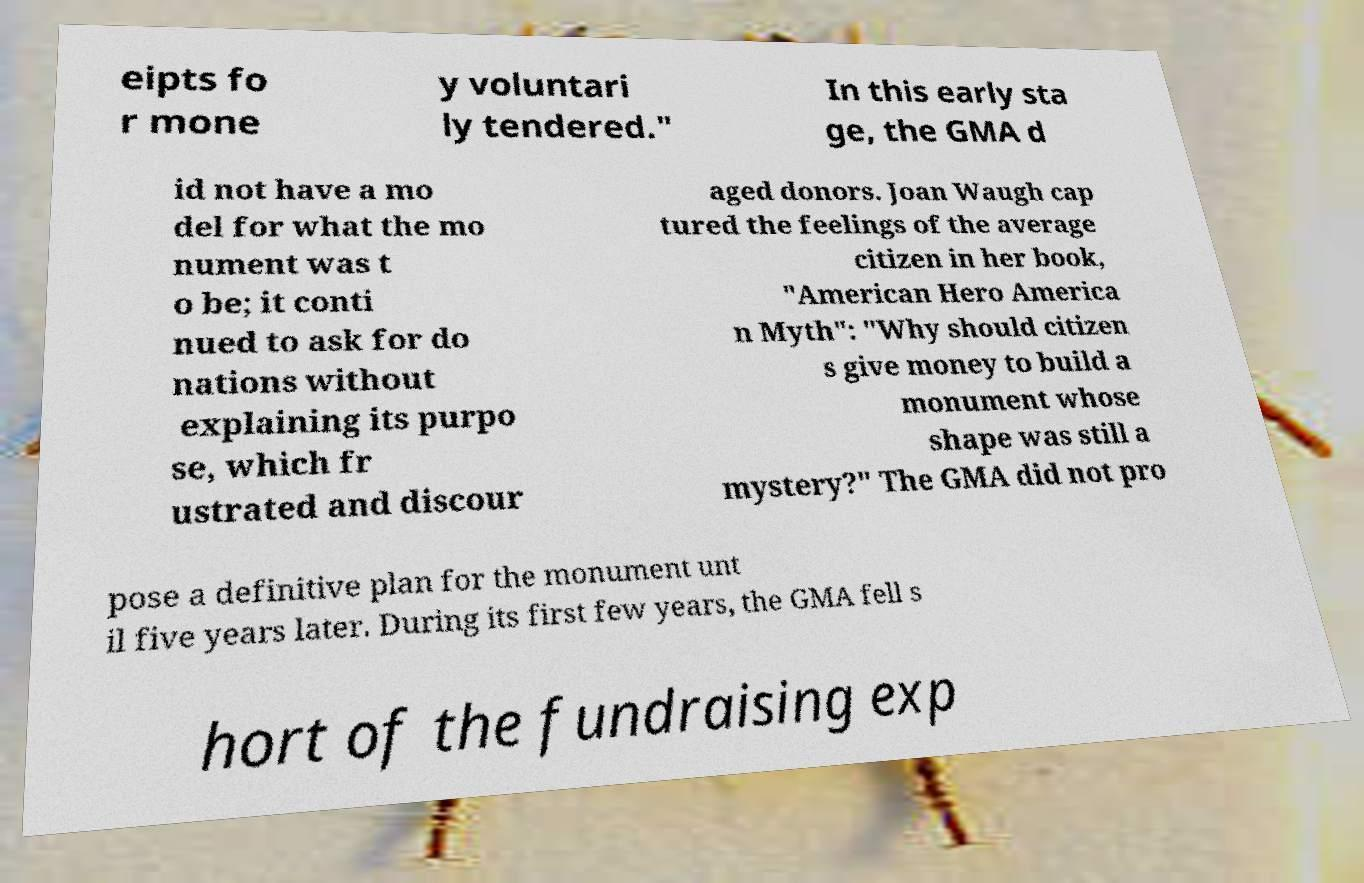Could you assist in decoding the text presented in this image and type it out clearly? eipts fo r mone y voluntari ly tendered." In this early sta ge, the GMA d id not have a mo del for what the mo nument was t o be; it conti nued to ask for do nations without explaining its purpo se, which fr ustrated and discour aged donors. Joan Waugh cap tured the feelings of the average citizen in her book, "American Hero America n Myth": "Why should citizen s give money to build a monument whose shape was still a mystery?" The GMA did not pro pose a definitive plan for the monument unt il five years later. During its first few years, the GMA fell s hort of the fundraising exp 